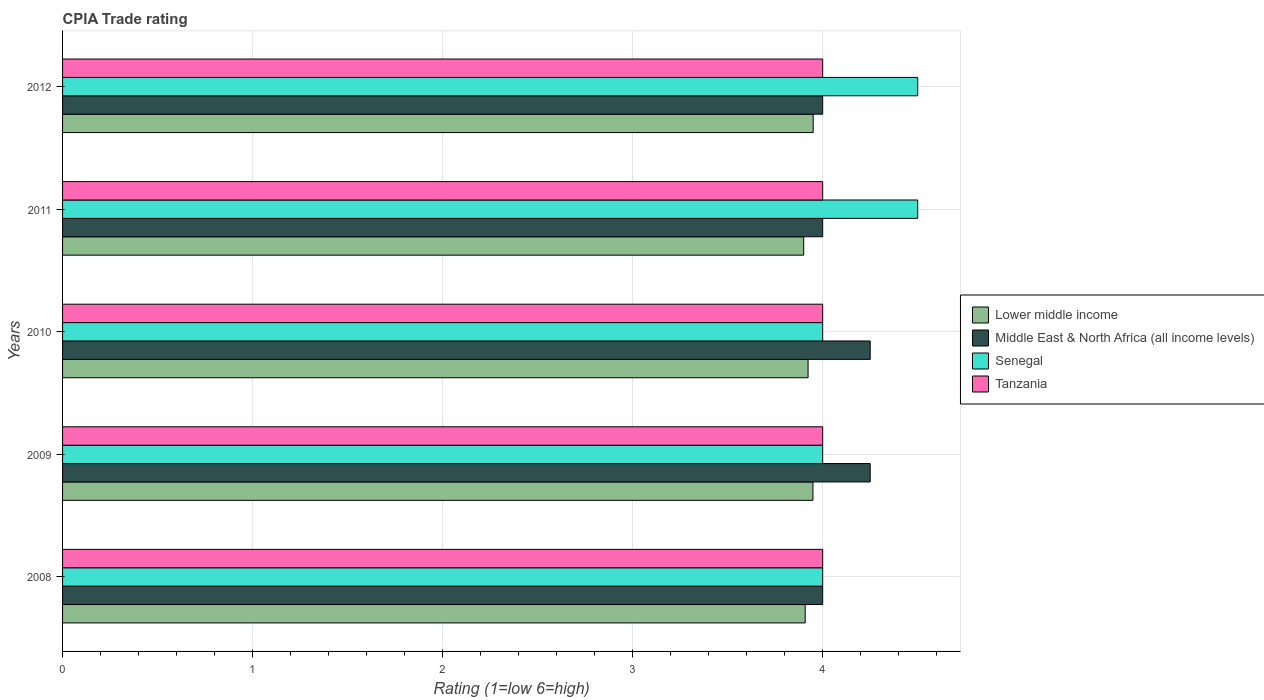How many different coloured bars are there?
Provide a short and direct response. 4. How many groups of bars are there?
Provide a short and direct response. 5. Are the number of bars per tick equal to the number of legend labels?
Your response must be concise. Yes. Are the number of bars on each tick of the Y-axis equal?
Offer a very short reply. Yes. What is the CPIA rating in Middle East & North Africa (all income levels) in 2009?
Your response must be concise. 4.25. Across all years, what is the maximum CPIA rating in Middle East & North Africa (all income levels)?
Your response must be concise. 4.25. What is the total CPIA rating in Tanzania in the graph?
Your answer should be very brief. 20. What is the difference between the CPIA rating in Senegal in 2008 and that in 2009?
Offer a terse response. 0. What is the difference between the CPIA rating in Lower middle income in 2010 and the CPIA rating in Middle East & North Africa (all income levels) in 2012?
Give a very brief answer. -0.08. What is the average CPIA rating in Lower middle income per year?
Your answer should be very brief. 3.93. In the year 2009, what is the difference between the CPIA rating in Senegal and CPIA rating in Middle East & North Africa (all income levels)?
Give a very brief answer. -0.25. In how many years, is the CPIA rating in Middle East & North Africa (all income levels) greater than 2.8 ?
Make the answer very short. 5. What is the ratio of the CPIA rating in Lower middle income in 2009 to that in 2011?
Offer a very short reply. 1.01. What is the difference between the highest and the second highest CPIA rating in Tanzania?
Offer a terse response. 0. In how many years, is the CPIA rating in Lower middle income greater than the average CPIA rating in Lower middle income taken over all years?
Provide a short and direct response. 2. Is the sum of the CPIA rating in Tanzania in 2009 and 2012 greater than the maximum CPIA rating in Lower middle income across all years?
Ensure brevity in your answer.  Yes. What does the 3rd bar from the top in 2008 represents?
Your answer should be very brief. Middle East & North Africa (all income levels). What does the 3rd bar from the bottom in 2012 represents?
Your response must be concise. Senegal. Are all the bars in the graph horizontal?
Provide a short and direct response. Yes. How many years are there in the graph?
Offer a terse response. 5. What is the difference between two consecutive major ticks on the X-axis?
Provide a succinct answer. 1. How many legend labels are there?
Provide a succinct answer. 4. How are the legend labels stacked?
Keep it short and to the point. Vertical. What is the title of the graph?
Offer a terse response. CPIA Trade rating. What is the label or title of the X-axis?
Provide a short and direct response. Rating (1=low 6=high). What is the Rating (1=low 6=high) of Lower middle income in 2008?
Your response must be concise. 3.91. What is the Rating (1=low 6=high) of Middle East & North Africa (all income levels) in 2008?
Make the answer very short. 4. What is the Rating (1=low 6=high) of Tanzania in 2008?
Give a very brief answer. 4. What is the Rating (1=low 6=high) of Lower middle income in 2009?
Provide a succinct answer. 3.95. What is the Rating (1=low 6=high) of Middle East & North Africa (all income levels) in 2009?
Offer a very short reply. 4.25. What is the Rating (1=low 6=high) in Senegal in 2009?
Give a very brief answer. 4. What is the Rating (1=low 6=high) in Lower middle income in 2010?
Provide a succinct answer. 3.92. What is the Rating (1=low 6=high) in Middle East & North Africa (all income levels) in 2010?
Keep it short and to the point. 4.25. What is the Rating (1=low 6=high) in Senegal in 2010?
Ensure brevity in your answer.  4. What is the Rating (1=low 6=high) of Tanzania in 2010?
Provide a succinct answer. 4. What is the Rating (1=low 6=high) of Lower middle income in 2011?
Offer a very short reply. 3.9. What is the Rating (1=low 6=high) of Middle East & North Africa (all income levels) in 2011?
Provide a succinct answer. 4. What is the Rating (1=low 6=high) in Senegal in 2011?
Your response must be concise. 4.5. What is the Rating (1=low 6=high) in Tanzania in 2011?
Ensure brevity in your answer.  4. What is the Rating (1=low 6=high) in Lower middle income in 2012?
Provide a short and direct response. 3.95. What is the Rating (1=low 6=high) in Middle East & North Africa (all income levels) in 2012?
Make the answer very short. 4. Across all years, what is the maximum Rating (1=low 6=high) of Lower middle income?
Your response must be concise. 3.95. Across all years, what is the maximum Rating (1=low 6=high) of Middle East & North Africa (all income levels)?
Make the answer very short. 4.25. Across all years, what is the maximum Rating (1=low 6=high) in Tanzania?
Offer a terse response. 4. What is the total Rating (1=low 6=high) in Lower middle income in the graph?
Keep it short and to the point. 19.63. What is the difference between the Rating (1=low 6=high) of Lower middle income in 2008 and that in 2009?
Offer a very short reply. -0.04. What is the difference between the Rating (1=low 6=high) of Senegal in 2008 and that in 2009?
Keep it short and to the point. 0. What is the difference between the Rating (1=low 6=high) of Tanzania in 2008 and that in 2009?
Offer a very short reply. 0. What is the difference between the Rating (1=low 6=high) in Lower middle income in 2008 and that in 2010?
Keep it short and to the point. -0.02. What is the difference between the Rating (1=low 6=high) in Lower middle income in 2008 and that in 2011?
Your response must be concise. 0.01. What is the difference between the Rating (1=low 6=high) in Tanzania in 2008 and that in 2011?
Ensure brevity in your answer.  0. What is the difference between the Rating (1=low 6=high) of Lower middle income in 2008 and that in 2012?
Offer a terse response. -0.04. What is the difference between the Rating (1=low 6=high) of Lower middle income in 2009 and that in 2010?
Your response must be concise. 0.03. What is the difference between the Rating (1=low 6=high) in Middle East & North Africa (all income levels) in 2009 and that in 2010?
Provide a short and direct response. 0. What is the difference between the Rating (1=low 6=high) in Lower middle income in 2009 and that in 2011?
Make the answer very short. 0.05. What is the difference between the Rating (1=low 6=high) in Middle East & North Africa (all income levels) in 2009 and that in 2011?
Provide a short and direct response. 0.25. What is the difference between the Rating (1=low 6=high) in Senegal in 2009 and that in 2011?
Make the answer very short. -0.5. What is the difference between the Rating (1=low 6=high) of Tanzania in 2009 and that in 2011?
Provide a short and direct response. 0. What is the difference between the Rating (1=low 6=high) in Lower middle income in 2009 and that in 2012?
Offer a terse response. -0. What is the difference between the Rating (1=low 6=high) in Middle East & North Africa (all income levels) in 2009 and that in 2012?
Your answer should be very brief. 0.25. What is the difference between the Rating (1=low 6=high) of Tanzania in 2009 and that in 2012?
Make the answer very short. 0. What is the difference between the Rating (1=low 6=high) of Lower middle income in 2010 and that in 2011?
Offer a very short reply. 0.02. What is the difference between the Rating (1=low 6=high) of Senegal in 2010 and that in 2011?
Provide a succinct answer. -0.5. What is the difference between the Rating (1=low 6=high) of Tanzania in 2010 and that in 2011?
Keep it short and to the point. 0. What is the difference between the Rating (1=low 6=high) in Lower middle income in 2010 and that in 2012?
Your answer should be compact. -0.03. What is the difference between the Rating (1=low 6=high) in Senegal in 2010 and that in 2012?
Your answer should be very brief. -0.5. What is the difference between the Rating (1=low 6=high) in Tanzania in 2010 and that in 2012?
Make the answer very short. 0. What is the difference between the Rating (1=low 6=high) in Lower middle income in 2011 and that in 2012?
Your answer should be compact. -0.05. What is the difference between the Rating (1=low 6=high) in Middle East & North Africa (all income levels) in 2011 and that in 2012?
Your answer should be very brief. 0. What is the difference between the Rating (1=low 6=high) of Senegal in 2011 and that in 2012?
Provide a succinct answer. 0. What is the difference between the Rating (1=low 6=high) in Tanzania in 2011 and that in 2012?
Ensure brevity in your answer.  0. What is the difference between the Rating (1=low 6=high) of Lower middle income in 2008 and the Rating (1=low 6=high) of Middle East & North Africa (all income levels) in 2009?
Keep it short and to the point. -0.34. What is the difference between the Rating (1=low 6=high) in Lower middle income in 2008 and the Rating (1=low 6=high) in Senegal in 2009?
Give a very brief answer. -0.09. What is the difference between the Rating (1=low 6=high) of Lower middle income in 2008 and the Rating (1=low 6=high) of Tanzania in 2009?
Offer a terse response. -0.09. What is the difference between the Rating (1=low 6=high) in Middle East & North Africa (all income levels) in 2008 and the Rating (1=low 6=high) in Senegal in 2009?
Keep it short and to the point. 0. What is the difference between the Rating (1=low 6=high) in Lower middle income in 2008 and the Rating (1=low 6=high) in Middle East & North Africa (all income levels) in 2010?
Give a very brief answer. -0.34. What is the difference between the Rating (1=low 6=high) of Lower middle income in 2008 and the Rating (1=low 6=high) of Senegal in 2010?
Offer a terse response. -0.09. What is the difference between the Rating (1=low 6=high) of Lower middle income in 2008 and the Rating (1=low 6=high) of Tanzania in 2010?
Offer a very short reply. -0.09. What is the difference between the Rating (1=low 6=high) in Middle East & North Africa (all income levels) in 2008 and the Rating (1=low 6=high) in Senegal in 2010?
Ensure brevity in your answer.  0. What is the difference between the Rating (1=low 6=high) in Middle East & North Africa (all income levels) in 2008 and the Rating (1=low 6=high) in Tanzania in 2010?
Make the answer very short. 0. What is the difference between the Rating (1=low 6=high) of Senegal in 2008 and the Rating (1=low 6=high) of Tanzania in 2010?
Provide a short and direct response. 0. What is the difference between the Rating (1=low 6=high) of Lower middle income in 2008 and the Rating (1=low 6=high) of Middle East & North Africa (all income levels) in 2011?
Provide a succinct answer. -0.09. What is the difference between the Rating (1=low 6=high) of Lower middle income in 2008 and the Rating (1=low 6=high) of Senegal in 2011?
Your response must be concise. -0.59. What is the difference between the Rating (1=low 6=high) of Lower middle income in 2008 and the Rating (1=low 6=high) of Tanzania in 2011?
Provide a short and direct response. -0.09. What is the difference between the Rating (1=low 6=high) of Middle East & North Africa (all income levels) in 2008 and the Rating (1=low 6=high) of Tanzania in 2011?
Offer a very short reply. 0. What is the difference between the Rating (1=low 6=high) in Senegal in 2008 and the Rating (1=low 6=high) in Tanzania in 2011?
Ensure brevity in your answer.  0. What is the difference between the Rating (1=low 6=high) in Lower middle income in 2008 and the Rating (1=low 6=high) in Middle East & North Africa (all income levels) in 2012?
Your answer should be compact. -0.09. What is the difference between the Rating (1=low 6=high) in Lower middle income in 2008 and the Rating (1=low 6=high) in Senegal in 2012?
Provide a short and direct response. -0.59. What is the difference between the Rating (1=low 6=high) of Lower middle income in 2008 and the Rating (1=low 6=high) of Tanzania in 2012?
Keep it short and to the point. -0.09. What is the difference between the Rating (1=low 6=high) of Middle East & North Africa (all income levels) in 2008 and the Rating (1=low 6=high) of Senegal in 2012?
Provide a short and direct response. -0.5. What is the difference between the Rating (1=low 6=high) in Middle East & North Africa (all income levels) in 2008 and the Rating (1=low 6=high) in Tanzania in 2012?
Provide a short and direct response. 0. What is the difference between the Rating (1=low 6=high) of Lower middle income in 2009 and the Rating (1=low 6=high) of Middle East & North Africa (all income levels) in 2010?
Offer a very short reply. -0.3. What is the difference between the Rating (1=low 6=high) in Lower middle income in 2009 and the Rating (1=low 6=high) in Senegal in 2010?
Your response must be concise. -0.05. What is the difference between the Rating (1=low 6=high) of Lower middle income in 2009 and the Rating (1=low 6=high) of Tanzania in 2010?
Your answer should be compact. -0.05. What is the difference between the Rating (1=low 6=high) of Middle East & North Africa (all income levels) in 2009 and the Rating (1=low 6=high) of Senegal in 2010?
Offer a terse response. 0.25. What is the difference between the Rating (1=low 6=high) in Lower middle income in 2009 and the Rating (1=low 6=high) in Middle East & North Africa (all income levels) in 2011?
Keep it short and to the point. -0.05. What is the difference between the Rating (1=low 6=high) in Lower middle income in 2009 and the Rating (1=low 6=high) in Senegal in 2011?
Your response must be concise. -0.55. What is the difference between the Rating (1=low 6=high) in Lower middle income in 2009 and the Rating (1=low 6=high) in Tanzania in 2011?
Give a very brief answer. -0.05. What is the difference between the Rating (1=low 6=high) in Middle East & North Africa (all income levels) in 2009 and the Rating (1=low 6=high) in Senegal in 2011?
Keep it short and to the point. -0.25. What is the difference between the Rating (1=low 6=high) in Senegal in 2009 and the Rating (1=low 6=high) in Tanzania in 2011?
Provide a succinct answer. 0. What is the difference between the Rating (1=low 6=high) of Lower middle income in 2009 and the Rating (1=low 6=high) of Middle East & North Africa (all income levels) in 2012?
Provide a short and direct response. -0.05. What is the difference between the Rating (1=low 6=high) of Lower middle income in 2009 and the Rating (1=low 6=high) of Senegal in 2012?
Keep it short and to the point. -0.55. What is the difference between the Rating (1=low 6=high) in Lower middle income in 2009 and the Rating (1=low 6=high) in Tanzania in 2012?
Give a very brief answer. -0.05. What is the difference between the Rating (1=low 6=high) of Middle East & North Africa (all income levels) in 2009 and the Rating (1=low 6=high) of Senegal in 2012?
Your answer should be very brief. -0.25. What is the difference between the Rating (1=low 6=high) of Senegal in 2009 and the Rating (1=low 6=high) of Tanzania in 2012?
Offer a terse response. 0. What is the difference between the Rating (1=low 6=high) of Lower middle income in 2010 and the Rating (1=low 6=high) of Middle East & North Africa (all income levels) in 2011?
Your answer should be very brief. -0.08. What is the difference between the Rating (1=low 6=high) of Lower middle income in 2010 and the Rating (1=low 6=high) of Senegal in 2011?
Give a very brief answer. -0.58. What is the difference between the Rating (1=low 6=high) of Lower middle income in 2010 and the Rating (1=low 6=high) of Tanzania in 2011?
Ensure brevity in your answer.  -0.08. What is the difference between the Rating (1=low 6=high) of Senegal in 2010 and the Rating (1=low 6=high) of Tanzania in 2011?
Keep it short and to the point. 0. What is the difference between the Rating (1=low 6=high) in Lower middle income in 2010 and the Rating (1=low 6=high) in Middle East & North Africa (all income levels) in 2012?
Keep it short and to the point. -0.08. What is the difference between the Rating (1=low 6=high) in Lower middle income in 2010 and the Rating (1=low 6=high) in Senegal in 2012?
Your response must be concise. -0.58. What is the difference between the Rating (1=low 6=high) of Lower middle income in 2010 and the Rating (1=low 6=high) of Tanzania in 2012?
Your answer should be very brief. -0.08. What is the difference between the Rating (1=low 6=high) of Middle East & North Africa (all income levels) in 2010 and the Rating (1=low 6=high) of Senegal in 2012?
Ensure brevity in your answer.  -0.25. What is the difference between the Rating (1=low 6=high) in Senegal in 2010 and the Rating (1=low 6=high) in Tanzania in 2012?
Your response must be concise. 0. What is the difference between the Rating (1=low 6=high) in Lower middle income in 2011 and the Rating (1=low 6=high) in Middle East & North Africa (all income levels) in 2012?
Offer a very short reply. -0.1. What is the difference between the Rating (1=low 6=high) in Lower middle income in 2011 and the Rating (1=low 6=high) in Senegal in 2012?
Your answer should be compact. -0.6. What is the difference between the Rating (1=low 6=high) of Middle East & North Africa (all income levels) in 2011 and the Rating (1=low 6=high) of Senegal in 2012?
Give a very brief answer. -0.5. What is the difference between the Rating (1=low 6=high) in Middle East & North Africa (all income levels) in 2011 and the Rating (1=low 6=high) in Tanzania in 2012?
Provide a short and direct response. 0. What is the difference between the Rating (1=low 6=high) of Senegal in 2011 and the Rating (1=low 6=high) of Tanzania in 2012?
Your answer should be very brief. 0.5. What is the average Rating (1=low 6=high) in Lower middle income per year?
Give a very brief answer. 3.93. What is the average Rating (1=low 6=high) of Middle East & North Africa (all income levels) per year?
Your response must be concise. 4.1. What is the average Rating (1=low 6=high) of Tanzania per year?
Offer a terse response. 4. In the year 2008, what is the difference between the Rating (1=low 6=high) of Lower middle income and Rating (1=low 6=high) of Middle East & North Africa (all income levels)?
Offer a terse response. -0.09. In the year 2008, what is the difference between the Rating (1=low 6=high) in Lower middle income and Rating (1=low 6=high) in Senegal?
Offer a very short reply. -0.09. In the year 2008, what is the difference between the Rating (1=low 6=high) in Lower middle income and Rating (1=low 6=high) in Tanzania?
Provide a short and direct response. -0.09. In the year 2008, what is the difference between the Rating (1=low 6=high) of Middle East & North Africa (all income levels) and Rating (1=low 6=high) of Senegal?
Offer a terse response. 0. In the year 2008, what is the difference between the Rating (1=low 6=high) in Middle East & North Africa (all income levels) and Rating (1=low 6=high) in Tanzania?
Your response must be concise. 0. In the year 2009, what is the difference between the Rating (1=low 6=high) of Lower middle income and Rating (1=low 6=high) of Middle East & North Africa (all income levels)?
Ensure brevity in your answer.  -0.3. In the year 2009, what is the difference between the Rating (1=low 6=high) of Lower middle income and Rating (1=low 6=high) of Senegal?
Provide a succinct answer. -0.05. In the year 2009, what is the difference between the Rating (1=low 6=high) in Lower middle income and Rating (1=low 6=high) in Tanzania?
Keep it short and to the point. -0.05. In the year 2009, what is the difference between the Rating (1=low 6=high) in Middle East & North Africa (all income levels) and Rating (1=low 6=high) in Senegal?
Your answer should be compact. 0.25. In the year 2009, what is the difference between the Rating (1=low 6=high) in Senegal and Rating (1=low 6=high) in Tanzania?
Offer a terse response. 0. In the year 2010, what is the difference between the Rating (1=low 6=high) of Lower middle income and Rating (1=low 6=high) of Middle East & North Africa (all income levels)?
Make the answer very short. -0.33. In the year 2010, what is the difference between the Rating (1=low 6=high) in Lower middle income and Rating (1=low 6=high) in Senegal?
Provide a short and direct response. -0.08. In the year 2010, what is the difference between the Rating (1=low 6=high) of Lower middle income and Rating (1=low 6=high) of Tanzania?
Your answer should be very brief. -0.08. In the year 2010, what is the difference between the Rating (1=low 6=high) of Middle East & North Africa (all income levels) and Rating (1=low 6=high) of Senegal?
Keep it short and to the point. 0.25. In the year 2010, what is the difference between the Rating (1=low 6=high) in Middle East & North Africa (all income levels) and Rating (1=low 6=high) in Tanzania?
Provide a short and direct response. 0.25. In the year 2011, what is the difference between the Rating (1=low 6=high) of Lower middle income and Rating (1=low 6=high) of Middle East & North Africa (all income levels)?
Make the answer very short. -0.1. In the year 2011, what is the difference between the Rating (1=low 6=high) of Lower middle income and Rating (1=low 6=high) of Tanzania?
Provide a short and direct response. -0.1. In the year 2011, what is the difference between the Rating (1=low 6=high) in Middle East & North Africa (all income levels) and Rating (1=low 6=high) in Senegal?
Provide a short and direct response. -0.5. In the year 2011, what is the difference between the Rating (1=low 6=high) of Middle East & North Africa (all income levels) and Rating (1=low 6=high) of Tanzania?
Your answer should be very brief. 0. In the year 2011, what is the difference between the Rating (1=low 6=high) in Senegal and Rating (1=low 6=high) in Tanzania?
Ensure brevity in your answer.  0.5. In the year 2012, what is the difference between the Rating (1=low 6=high) in Lower middle income and Rating (1=low 6=high) in Senegal?
Your answer should be compact. -0.55. In the year 2012, what is the difference between the Rating (1=low 6=high) in Middle East & North Africa (all income levels) and Rating (1=low 6=high) in Tanzania?
Give a very brief answer. 0. In the year 2012, what is the difference between the Rating (1=low 6=high) in Senegal and Rating (1=low 6=high) in Tanzania?
Keep it short and to the point. 0.5. What is the ratio of the Rating (1=low 6=high) in Middle East & North Africa (all income levels) in 2008 to that in 2009?
Your answer should be very brief. 0.94. What is the ratio of the Rating (1=low 6=high) of Tanzania in 2008 to that in 2009?
Offer a terse response. 1. What is the ratio of the Rating (1=low 6=high) in Lower middle income in 2008 to that in 2010?
Provide a short and direct response. 1. What is the ratio of the Rating (1=low 6=high) of Middle East & North Africa (all income levels) in 2008 to that in 2010?
Provide a succinct answer. 0.94. What is the ratio of the Rating (1=low 6=high) of Tanzania in 2008 to that in 2010?
Your response must be concise. 1. What is the ratio of the Rating (1=low 6=high) in Lower middle income in 2008 to that in 2011?
Your response must be concise. 1. What is the ratio of the Rating (1=low 6=high) in Middle East & North Africa (all income levels) in 2008 to that in 2011?
Provide a succinct answer. 1. What is the ratio of the Rating (1=low 6=high) in Tanzania in 2008 to that in 2011?
Your answer should be very brief. 1. What is the ratio of the Rating (1=low 6=high) in Lower middle income in 2008 to that in 2012?
Make the answer very short. 0.99. What is the ratio of the Rating (1=low 6=high) in Middle East & North Africa (all income levels) in 2008 to that in 2012?
Provide a short and direct response. 1. What is the ratio of the Rating (1=low 6=high) of Lower middle income in 2009 to that in 2010?
Provide a short and direct response. 1.01. What is the ratio of the Rating (1=low 6=high) of Middle East & North Africa (all income levels) in 2009 to that in 2010?
Your answer should be compact. 1. What is the ratio of the Rating (1=low 6=high) of Lower middle income in 2009 to that in 2011?
Provide a succinct answer. 1.01. What is the ratio of the Rating (1=low 6=high) in Tanzania in 2009 to that in 2011?
Your answer should be compact. 1. What is the ratio of the Rating (1=low 6=high) in Lower middle income in 2009 to that in 2012?
Ensure brevity in your answer.  1. What is the ratio of the Rating (1=low 6=high) in Senegal in 2009 to that in 2012?
Your answer should be very brief. 0.89. What is the ratio of the Rating (1=low 6=high) in Lower middle income in 2010 to that in 2011?
Your response must be concise. 1.01. What is the ratio of the Rating (1=low 6=high) of Senegal in 2010 to that in 2012?
Your answer should be very brief. 0.89. What is the ratio of the Rating (1=low 6=high) in Tanzania in 2010 to that in 2012?
Offer a terse response. 1. What is the ratio of the Rating (1=low 6=high) in Lower middle income in 2011 to that in 2012?
Keep it short and to the point. 0.99. What is the difference between the highest and the second highest Rating (1=low 6=high) in Lower middle income?
Make the answer very short. 0. What is the difference between the highest and the lowest Rating (1=low 6=high) in Lower middle income?
Make the answer very short. 0.05. 